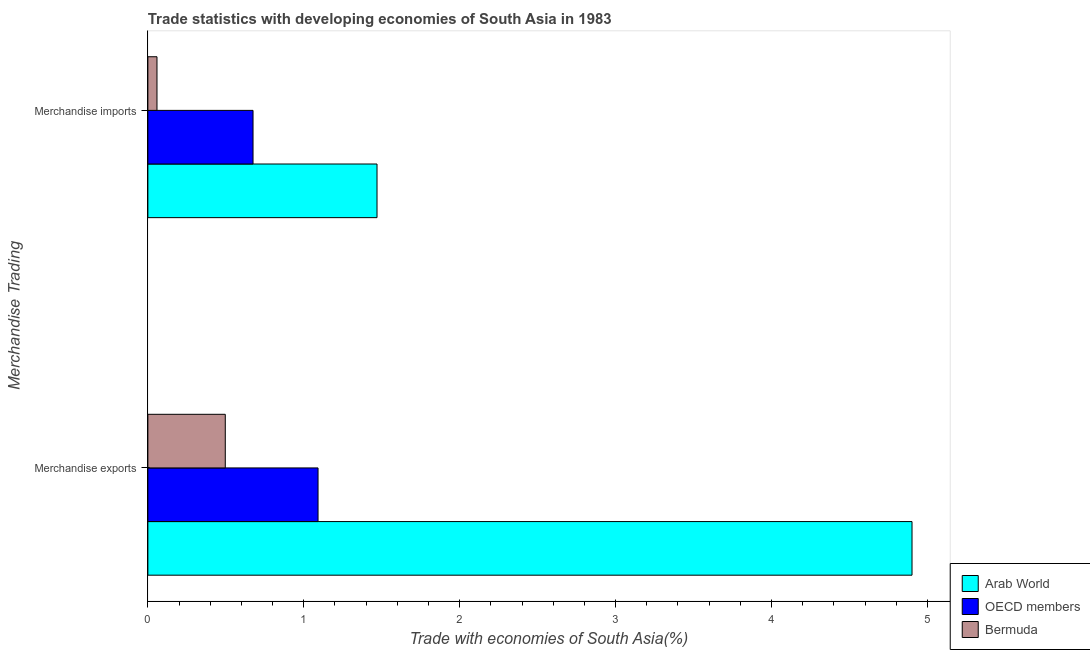How many groups of bars are there?
Your response must be concise. 2. Are the number of bars on each tick of the Y-axis equal?
Give a very brief answer. Yes. What is the label of the 2nd group of bars from the top?
Your answer should be very brief. Merchandise exports. What is the merchandise exports in OECD members?
Keep it short and to the point. 1.09. Across all countries, what is the maximum merchandise imports?
Offer a terse response. 1.47. Across all countries, what is the minimum merchandise exports?
Offer a very short reply. 0.5. In which country was the merchandise imports maximum?
Give a very brief answer. Arab World. In which country was the merchandise imports minimum?
Give a very brief answer. Bermuda. What is the total merchandise exports in the graph?
Make the answer very short. 6.49. What is the difference between the merchandise exports in OECD members and that in Bermuda?
Offer a terse response. 0.59. What is the difference between the merchandise exports in Arab World and the merchandise imports in OECD members?
Offer a very short reply. 4.23. What is the average merchandise exports per country?
Give a very brief answer. 2.16. What is the difference between the merchandise exports and merchandise imports in OECD members?
Keep it short and to the point. 0.42. What is the ratio of the merchandise exports in Arab World to that in Bermuda?
Give a very brief answer. 9.87. What does the 3rd bar from the top in Merchandise exports represents?
Offer a very short reply. Arab World. What does the 3rd bar from the bottom in Merchandise imports represents?
Provide a succinct answer. Bermuda. Are all the bars in the graph horizontal?
Keep it short and to the point. Yes. How many countries are there in the graph?
Make the answer very short. 3. Does the graph contain any zero values?
Provide a short and direct response. No. Does the graph contain grids?
Your answer should be compact. No. What is the title of the graph?
Keep it short and to the point. Trade statistics with developing economies of South Asia in 1983. Does "Samoa" appear as one of the legend labels in the graph?
Provide a succinct answer. No. What is the label or title of the X-axis?
Keep it short and to the point. Trade with economies of South Asia(%). What is the label or title of the Y-axis?
Your response must be concise. Merchandise Trading. What is the Trade with economies of South Asia(%) of Arab World in Merchandise exports?
Offer a very short reply. 4.9. What is the Trade with economies of South Asia(%) in OECD members in Merchandise exports?
Offer a terse response. 1.09. What is the Trade with economies of South Asia(%) in Bermuda in Merchandise exports?
Your answer should be very brief. 0.5. What is the Trade with economies of South Asia(%) in Arab World in Merchandise imports?
Provide a succinct answer. 1.47. What is the Trade with economies of South Asia(%) of OECD members in Merchandise imports?
Make the answer very short. 0.67. What is the Trade with economies of South Asia(%) in Bermuda in Merchandise imports?
Offer a very short reply. 0.06. Across all Merchandise Trading, what is the maximum Trade with economies of South Asia(%) in Arab World?
Ensure brevity in your answer.  4.9. Across all Merchandise Trading, what is the maximum Trade with economies of South Asia(%) in OECD members?
Provide a short and direct response. 1.09. Across all Merchandise Trading, what is the maximum Trade with economies of South Asia(%) of Bermuda?
Provide a succinct answer. 0.5. Across all Merchandise Trading, what is the minimum Trade with economies of South Asia(%) in Arab World?
Keep it short and to the point. 1.47. Across all Merchandise Trading, what is the minimum Trade with economies of South Asia(%) in OECD members?
Provide a succinct answer. 0.67. Across all Merchandise Trading, what is the minimum Trade with economies of South Asia(%) in Bermuda?
Provide a succinct answer. 0.06. What is the total Trade with economies of South Asia(%) in Arab World in the graph?
Give a very brief answer. 6.37. What is the total Trade with economies of South Asia(%) of OECD members in the graph?
Your response must be concise. 1.77. What is the total Trade with economies of South Asia(%) in Bermuda in the graph?
Provide a succinct answer. 0.56. What is the difference between the Trade with economies of South Asia(%) in Arab World in Merchandise exports and that in Merchandise imports?
Your answer should be very brief. 3.43. What is the difference between the Trade with economies of South Asia(%) of OECD members in Merchandise exports and that in Merchandise imports?
Provide a succinct answer. 0.42. What is the difference between the Trade with economies of South Asia(%) in Bermuda in Merchandise exports and that in Merchandise imports?
Your response must be concise. 0.44. What is the difference between the Trade with economies of South Asia(%) in Arab World in Merchandise exports and the Trade with economies of South Asia(%) in OECD members in Merchandise imports?
Offer a terse response. 4.23. What is the difference between the Trade with economies of South Asia(%) of Arab World in Merchandise exports and the Trade with economies of South Asia(%) of Bermuda in Merchandise imports?
Make the answer very short. 4.84. What is the difference between the Trade with economies of South Asia(%) of OECD members in Merchandise exports and the Trade with economies of South Asia(%) of Bermuda in Merchandise imports?
Ensure brevity in your answer.  1.03. What is the average Trade with economies of South Asia(%) of Arab World per Merchandise Trading?
Make the answer very short. 3.19. What is the average Trade with economies of South Asia(%) in OECD members per Merchandise Trading?
Make the answer very short. 0.88. What is the average Trade with economies of South Asia(%) in Bermuda per Merchandise Trading?
Your answer should be compact. 0.28. What is the difference between the Trade with economies of South Asia(%) in Arab World and Trade with economies of South Asia(%) in OECD members in Merchandise exports?
Your answer should be compact. 3.81. What is the difference between the Trade with economies of South Asia(%) in Arab World and Trade with economies of South Asia(%) in Bermuda in Merchandise exports?
Offer a terse response. 4.4. What is the difference between the Trade with economies of South Asia(%) in OECD members and Trade with economies of South Asia(%) in Bermuda in Merchandise exports?
Ensure brevity in your answer.  0.59. What is the difference between the Trade with economies of South Asia(%) of Arab World and Trade with economies of South Asia(%) of OECD members in Merchandise imports?
Provide a short and direct response. 0.8. What is the difference between the Trade with economies of South Asia(%) in Arab World and Trade with economies of South Asia(%) in Bermuda in Merchandise imports?
Offer a terse response. 1.41. What is the difference between the Trade with economies of South Asia(%) of OECD members and Trade with economies of South Asia(%) of Bermuda in Merchandise imports?
Provide a succinct answer. 0.62. What is the ratio of the Trade with economies of South Asia(%) in Arab World in Merchandise exports to that in Merchandise imports?
Offer a very short reply. 3.33. What is the ratio of the Trade with economies of South Asia(%) in OECD members in Merchandise exports to that in Merchandise imports?
Provide a succinct answer. 1.62. What is the ratio of the Trade with economies of South Asia(%) of Bermuda in Merchandise exports to that in Merchandise imports?
Your answer should be compact. 8.49. What is the difference between the highest and the second highest Trade with economies of South Asia(%) of Arab World?
Your answer should be very brief. 3.43. What is the difference between the highest and the second highest Trade with economies of South Asia(%) of OECD members?
Keep it short and to the point. 0.42. What is the difference between the highest and the second highest Trade with economies of South Asia(%) of Bermuda?
Provide a succinct answer. 0.44. What is the difference between the highest and the lowest Trade with economies of South Asia(%) in Arab World?
Your answer should be compact. 3.43. What is the difference between the highest and the lowest Trade with economies of South Asia(%) of OECD members?
Provide a short and direct response. 0.42. What is the difference between the highest and the lowest Trade with economies of South Asia(%) of Bermuda?
Provide a succinct answer. 0.44. 